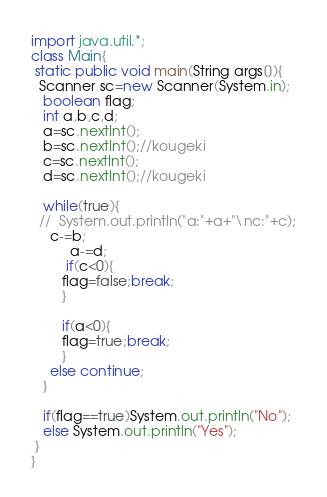Convert code to text. <code><loc_0><loc_0><loc_500><loc_500><_Java_>import java.util.*;
class Main{
 static public void main(String args[]){
  Scanner sc=new Scanner(System.in); 
   boolean flag;
   int a,b,c,d;
   a=sc.nextInt();
   b=sc.nextInt();//kougeki
   c=sc.nextInt();
   d=sc.nextInt();//kougeki
   
   while(true){
  // 	System.out.println("a:"+a+"\nc:"+c);
     c-=b;
	      a-=d;
	 	 if(c<0){
	 	flag=false;break;
		}

	    if(a<0){
	 	flag=true;break;
		}
	 else continue;
   }
   
   if(flag==true)System.out.println("No");
   else System.out.println("Yes");
 }
}</code> 